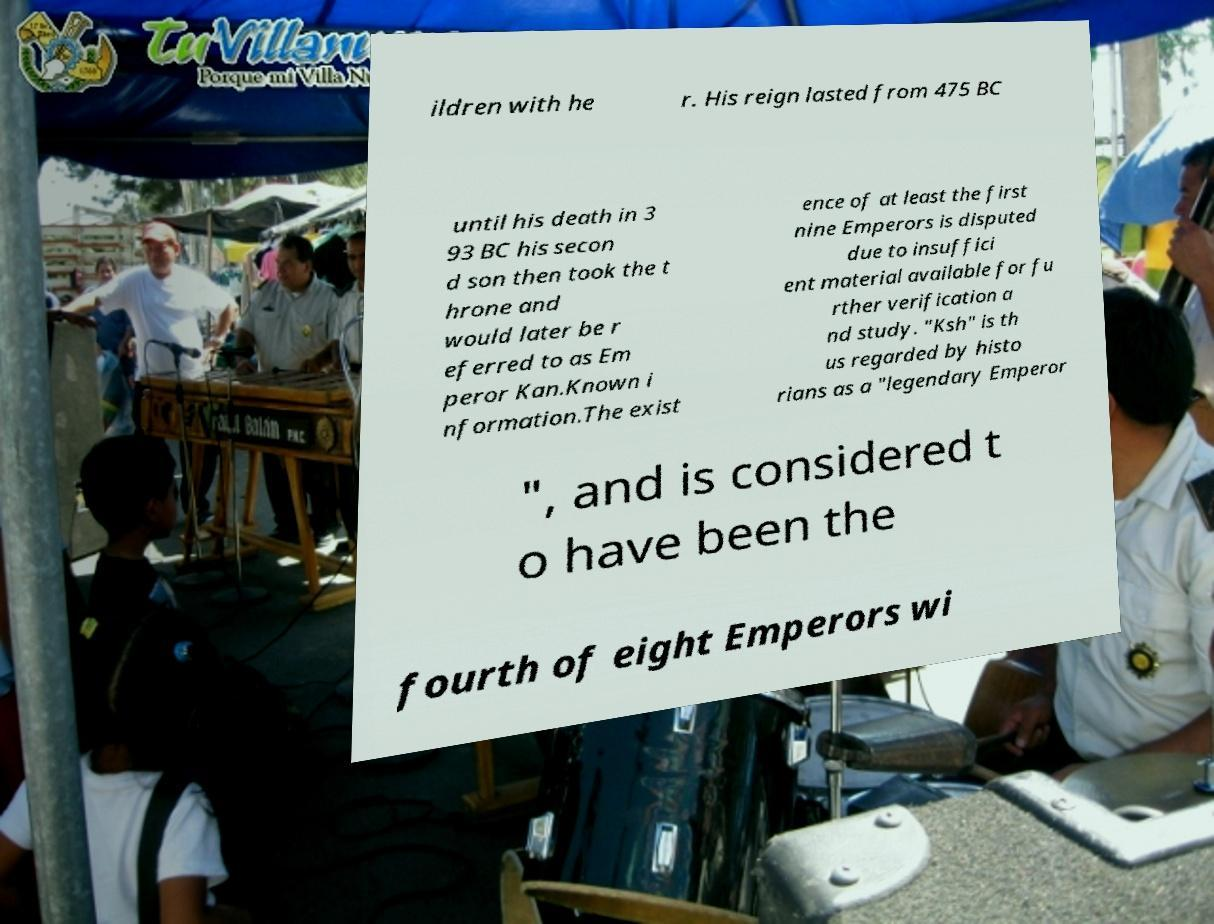Please identify and transcribe the text found in this image. ildren with he r. His reign lasted from 475 BC until his death in 3 93 BC his secon d son then took the t hrone and would later be r eferred to as Em peror Kan.Known i nformation.The exist ence of at least the first nine Emperors is disputed due to insuffici ent material available for fu rther verification a nd study. "Ksh" is th us regarded by histo rians as a "legendary Emperor ", and is considered t o have been the fourth of eight Emperors wi 